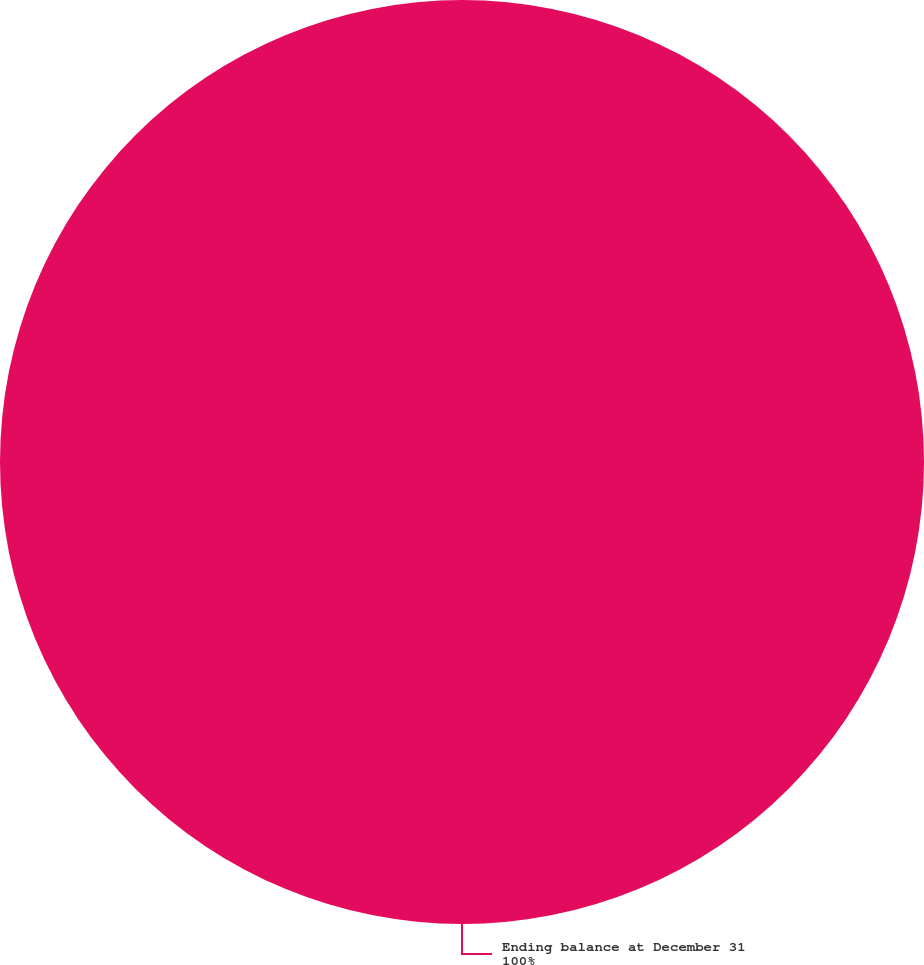<chart> <loc_0><loc_0><loc_500><loc_500><pie_chart><fcel>Ending balance at December 31<nl><fcel>100.0%<nl></chart> 